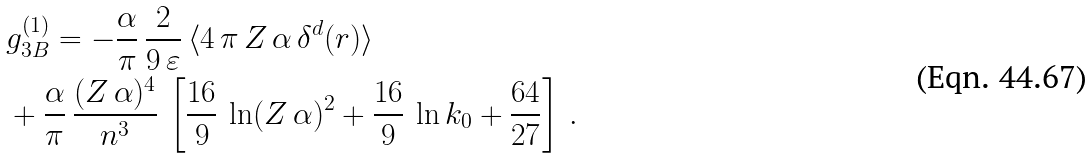<formula> <loc_0><loc_0><loc_500><loc_500>& g ^ { ( 1 ) } _ { 3 B } = - \frac { \alpha } { \pi } \, \frac { 2 } { 9 \, \varepsilon } \, \langle 4 \, \pi \, Z \, \alpha \, \delta ^ { d } ( r ) \rangle \\ & + \frac { \alpha } { \pi } \, \frac { ( Z \, \alpha ) ^ { 4 } } { n ^ { 3 } } \, \left [ \frac { 1 6 } { 9 } \, \ln ( Z \, \alpha ) ^ { 2 } + \frac { 1 6 } { 9 } \, \ln k _ { 0 } + \frac { 6 4 } { 2 7 } \right ] \, .</formula> 